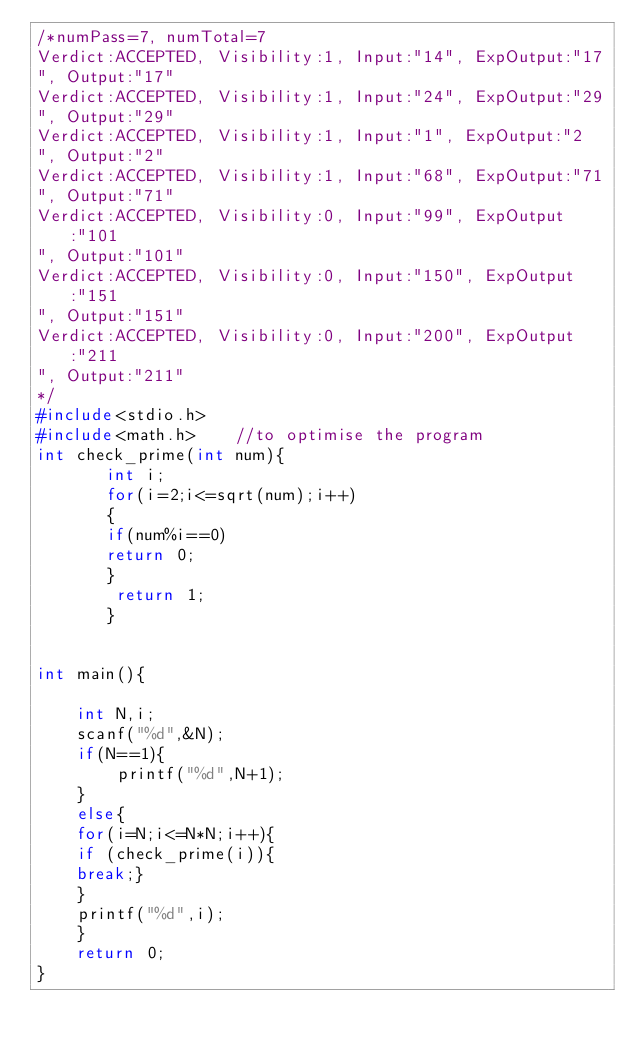<code> <loc_0><loc_0><loc_500><loc_500><_C_>/*numPass=7, numTotal=7
Verdict:ACCEPTED, Visibility:1, Input:"14", ExpOutput:"17
", Output:"17"
Verdict:ACCEPTED, Visibility:1, Input:"24", ExpOutput:"29
", Output:"29"
Verdict:ACCEPTED, Visibility:1, Input:"1", ExpOutput:"2
", Output:"2"
Verdict:ACCEPTED, Visibility:1, Input:"68", ExpOutput:"71
", Output:"71"
Verdict:ACCEPTED, Visibility:0, Input:"99", ExpOutput:"101
", Output:"101"
Verdict:ACCEPTED, Visibility:0, Input:"150", ExpOutput:"151
", Output:"151"
Verdict:ACCEPTED, Visibility:0, Input:"200", ExpOutput:"211
", Output:"211"
*/
#include<stdio.h>
#include<math.h>    //to optimise the program
int check_prime(int num){
       int i;
       for(i=2;i<=sqrt(num);i++)
       {
       if(num%i==0)
       return 0;
       }
        return 1;
       }
       
       
int main(){
    
    int N,i;
    scanf("%d",&N);
    if(N==1){
        printf("%d",N+1);
    }
    else{
    for(i=N;i<=N*N;i++){
    if (check_prime(i)){
    break;}
    }
    printf("%d",i);
    }
    return 0;
}</code> 